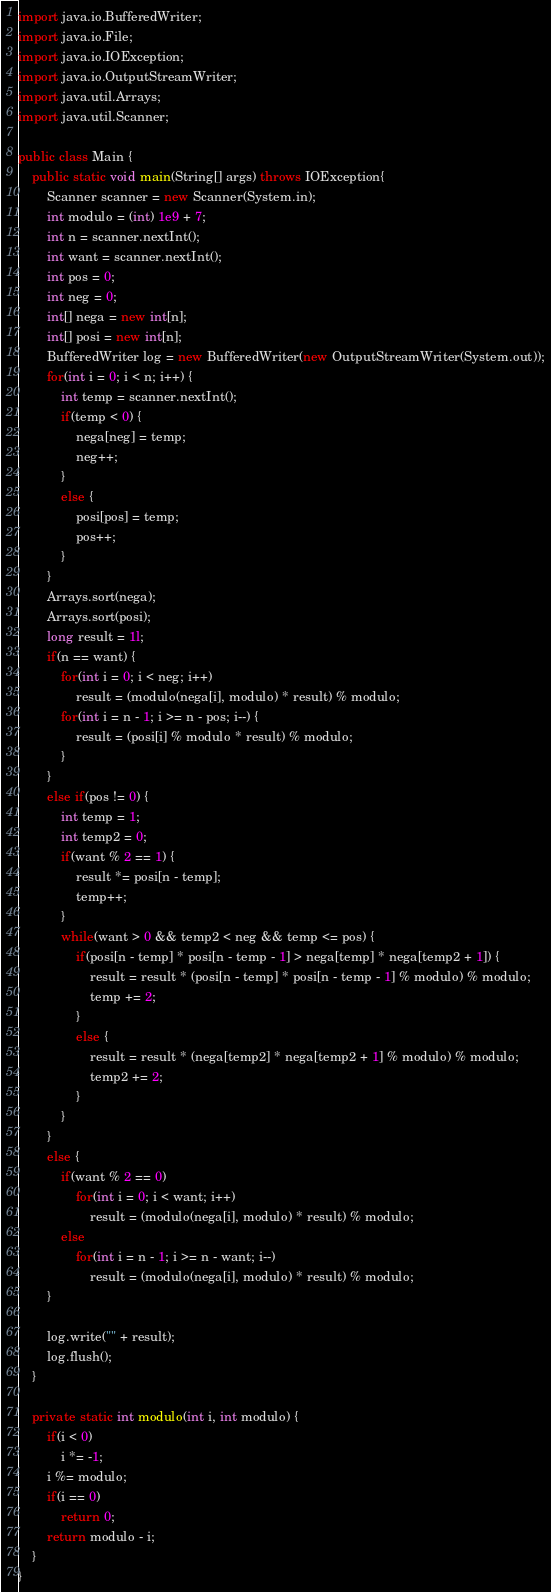<code> <loc_0><loc_0><loc_500><loc_500><_Java_>import java.io.BufferedWriter;
import java.io.File;
import java.io.IOException;
import java.io.OutputStreamWriter;
import java.util.Arrays;
import java.util.Scanner;

public class Main {
	public static void main(String[] args) throws IOException{
		Scanner scanner = new Scanner(System.in);
		int modulo = (int) 1e9 + 7;
		int n = scanner.nextInt();
		int want = scanner.nextInt();
		int pos = 0;
		int neg = 0;
		int[] nega = new int[n];
		int[] posi = new int[n];
		BufferedWriter log = new BufferedWriter(new OutputStreamWriter(System.out));
		for(int i = 0; i < n; i++) {
			int temp = scanner.nextInt();
			if(temp < 0) {
				nega[neg] = temp;
				neg++;
			}
			else {
				posi[pos] = temp;
				pos++;
			}
		}
		Arrays.sort(nega);
		Arrays.sort(posi);
		long result = 1l;
		if(n == want) {
			for(int i = 0; i < neg; i++)
				result = (modulo(nega[i], modulo) * result) % modulo;
			for(int i = n - 1; i >= n - pos; i--) {
				result = (posi[i] % modulo * result) % modulo;
			}
		}
		else if(pos != 0) {
			int temp = 1;
			int temp2 = 0;
			if(want % 2 == 1) {
				result *= posi[n - temp];
				temp++;
			}
			while(want > 0 && temp2 < neg && temp <= pos) {
				if(posi[n - temp] * posi[n - temp - 1] > nega[temp] * nega[temp2 + 1]) {
					result = result * (posi[n - temp] * posi[n - temp - 1] % modulo) % modulo;
					temp += 2;
				}
				else {
					result = result * (nega[temp2] * nega[temp2 + 1] % modulo) % modulo;
					temp2 += 2;
				}
			}
		}
		else {
			if(want % 2 == 0)
				for(int i = 0; i < want; i++)
					result = (modulo(nega[i], modulo) * result) % modulo;
			else
				for(int i = n - 1; i >= n - want; i--)
					result = (modulo(nega[i], modulo) * result) % modulo;
		}
		
		log.write("" + result);
		log.flush();
	}

	private static int modulo(int i, int modulo) {
		if(i < 0)
			i *= -1;
		i %= modulo;
		if(i == 0)
			return 0;
		return modulo - i;
	}
}
</code> 